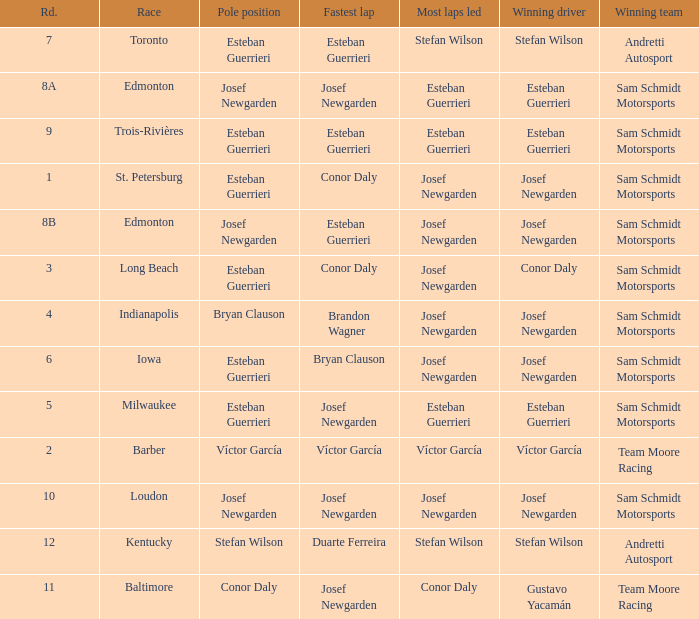Who had the fastest lap(s) when stefan wilson had the pole? Duarte Ferreira. 